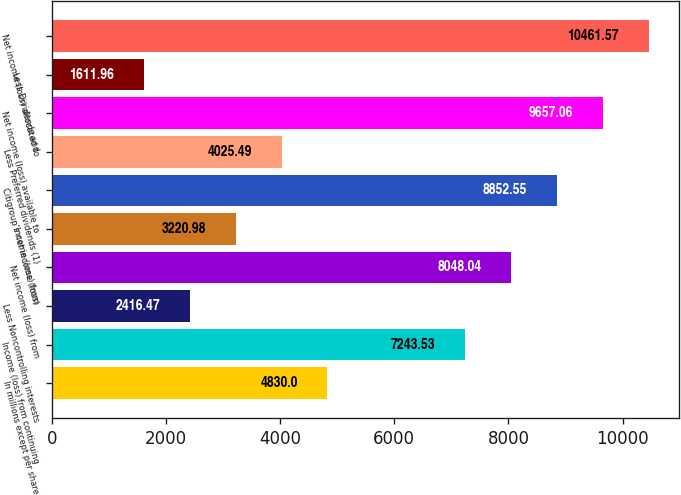<chart> <loc_0><loc_0><loc_500><loc_500><bar_chart><fcel>In millions except per share<fcel>Income (loss) from continuing<fcel>Less Noncontrolling interests<fcel>Net income (loss) from<fcel>Income (loss) from<fcel>Citigroup's net income (loss)<fcel>Less Preferred dividends (1)<fcel>Net income (loss) available to<fcel>Less Dividends and<fcel>Net income (loss) allocated to<nl><fcel>4830<fcel>7243.53<fcel>2416.47<fcel>8048.04<fcel>3220.98<fcel>8852.55<fcel>4025.49<fcel>9657.06<fcel>1611.96<fcel>10461.6<nl></chart> 